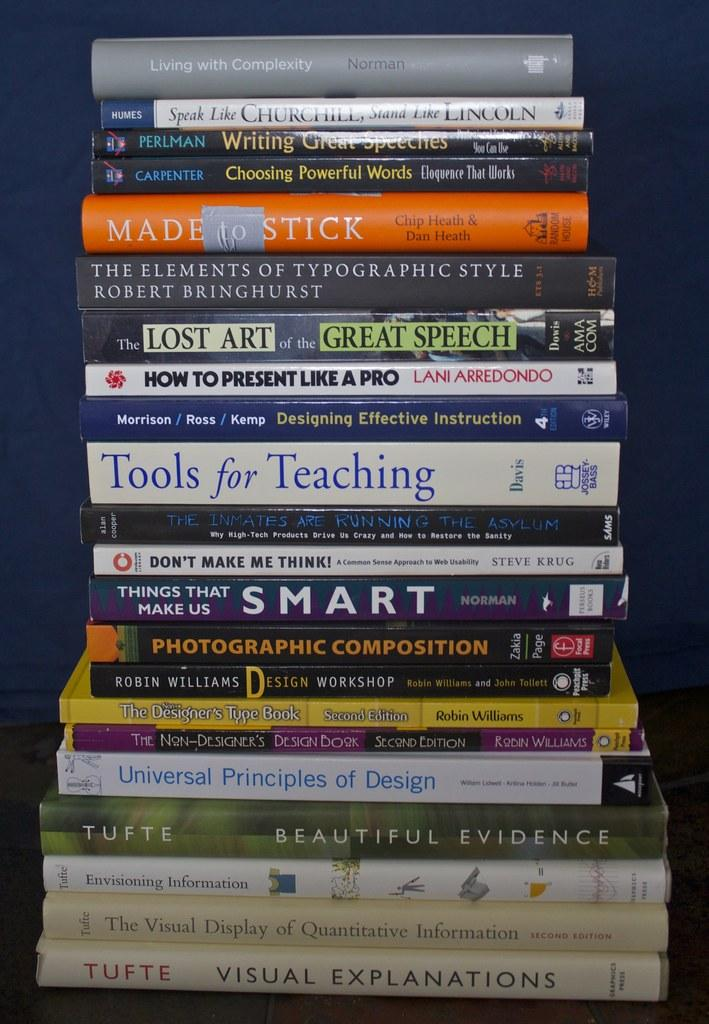What is the main subject of the image? The main subject of the image is a collection of books. How are the books arranged in the image? The books are stacked one upon the other. On what object are the books placed? The books are on an object, but the specific type of object is not mentioned in the facts. What is the angle at which the volleyball is positioned in the image? There is no volleyball present in the image, so it is not possible to determine the angle at which it might be positioned. 